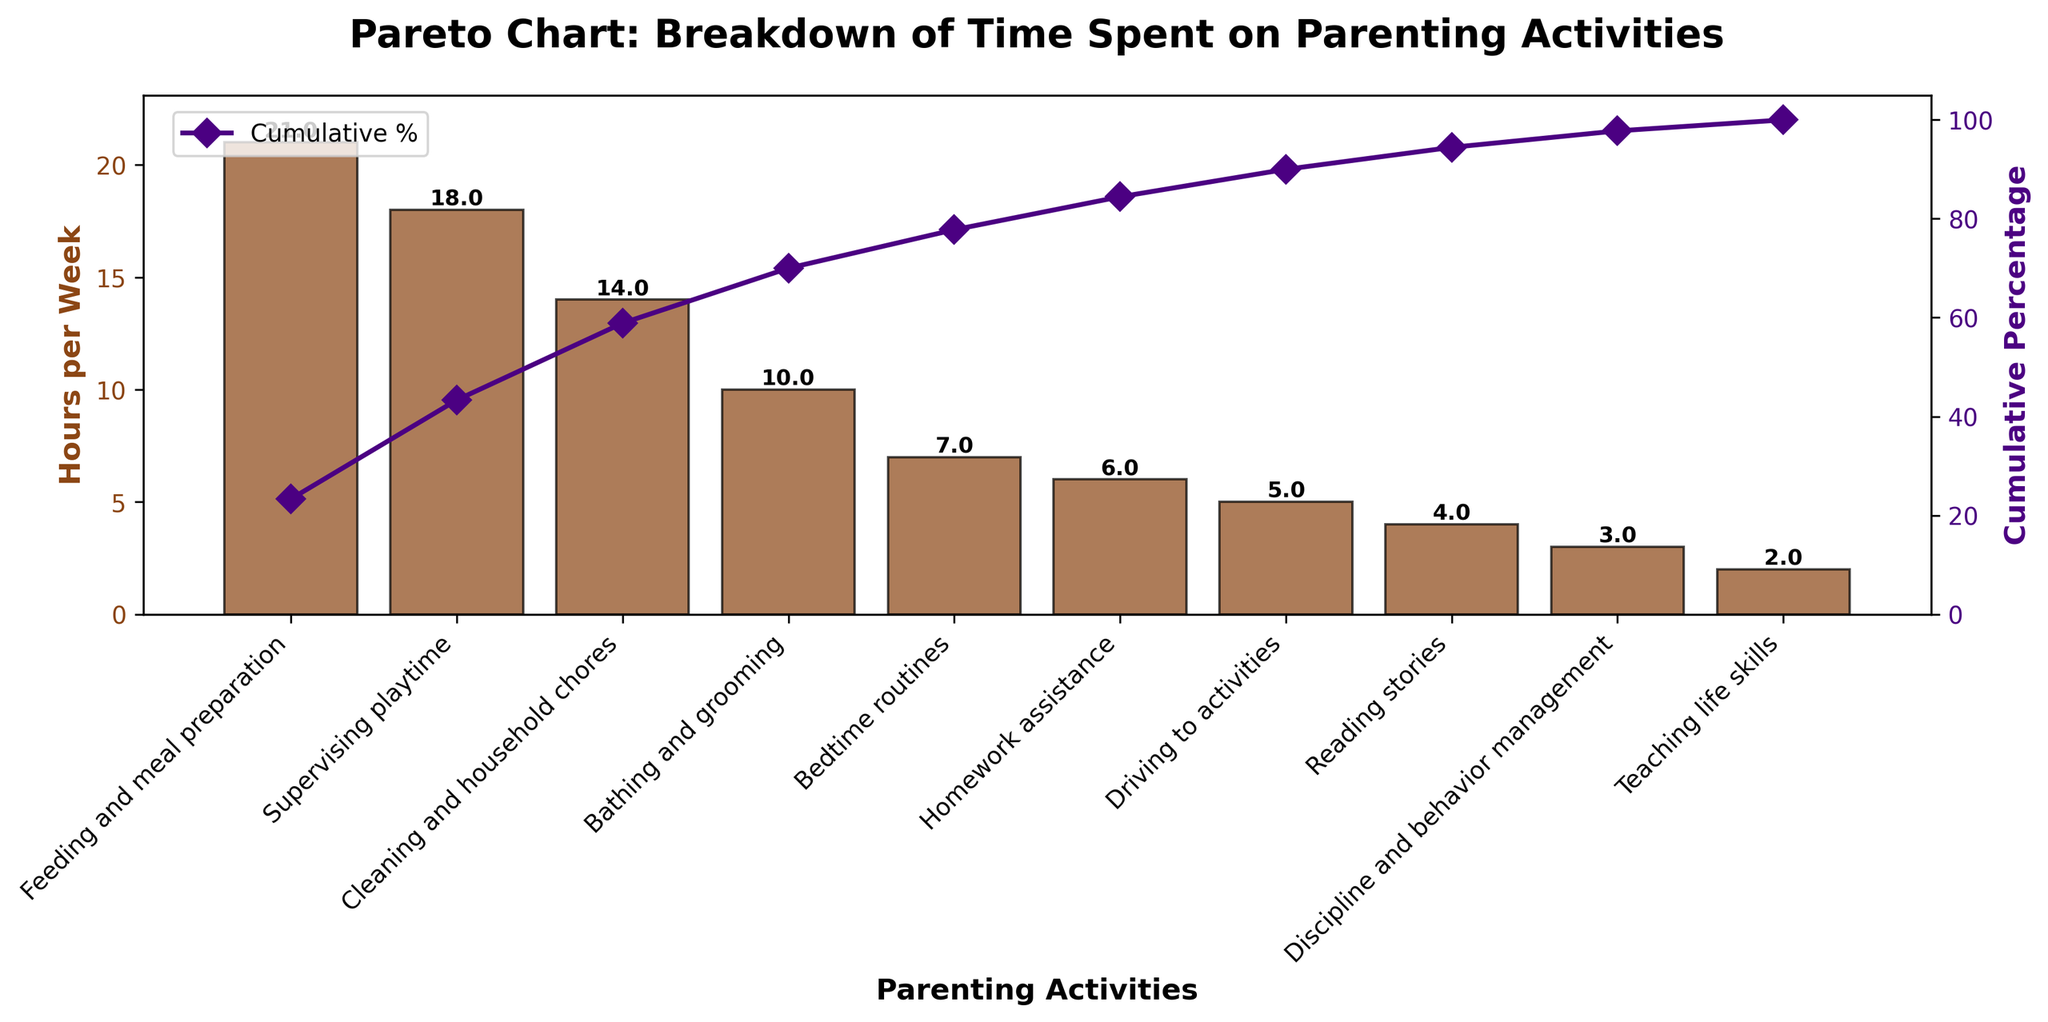What activity takes the most time per week? By looking at the height of the bars, the tallest bar represents the activity that takes the most time per week. In this case, it's 'Feeding and meal preparation' with 21 hours.
Answer: Feeding and meal preparation What is the cumulative percentage by the time we include 'Bathing and grooming'? The cumulative percentage line plot shows that the cumulative percentage is around 80% by the time we include 'Bathing and grooming'. This can be read directly from the secondary y-axis corresponding to the cumulative percentage.
Answer: 80% Which activity is the least time-consuming? The shortest bar on the plot represents the activity that takes the least time per week. This is 'Teaching life skills' with 2 hours.
Answer: Teaching life skills How many activities take up more than 10 hours per week? By looking at the heights of the bars, we can see that 'Feeding and meal preparation' (21 hours), 'Supervising playtime' (18 hours), and 'Cleaning and household chores' (14 hours) are the only activities that take more than 10 hours per week. Count these to get the answer.
Answer: 3 What's the difference in time spent between 'Driving to activities' and 'Reading stories'? The time spent on 'Driving to activities' is 5 hours per week and on 'Reading stories' is 4 hours per week. The difference is 5 - 4 = 1 hour.
Answer: 1 hour By how many hours does 'Feeding and meal preparation' exceed 'Cleaning and household chores'? 'Feeding and meal preparation' takes 21 hours, and 'Cleaning and household chores' takes 14 hours. The difference is 21 - 14 = 7 hours.
Answer: 7 hours Which activities combine to make up half of the total hours spent? By looking at the bar heights and cumulative percentage line, 'Feeding and meal preparation' (21 hours) and 'Supervising playtime' (18 hours) together make up about 49% of the total. Including 'Cleaning and household chores' (14 hours) would exceed half, so only the first two are considered.
Answer: Feeding and meal preparation and Supervising playtime How much more time is spent on 'Homework assistance' compared to 'Discipline and behavior management'? 'Homework assistance' takes 6 hours per week, and 'Discipline and behavior management' takes 3 hours. The difference is 6 - 3 = 3 hours.
Answer: 3 hours What cumulative percentage of total time is spent after 'Bedtime routines'? By observing the cumulative percentage line plot, the cumulative percentage after 'Bedtime routines' is approximately 85%.
Answer: 85% Which activity has a cumulative percentage close to 50%? The cumulative percentage line plot shows that 'Cleaning and household chores' reaches about 50%.
Answer: Cleaning and household chores 